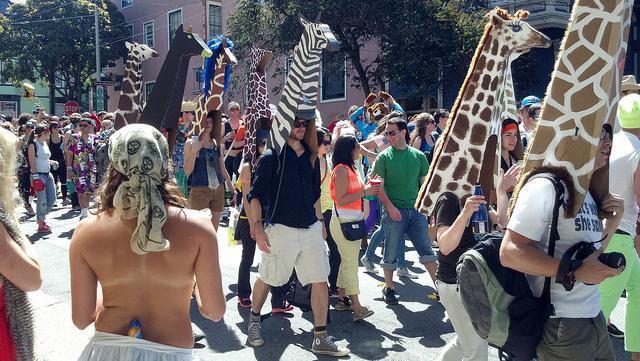How many giraffes can you see?
Give a very brief answer. 3. How many people are there?
Give a very brief answer. 9. How many of the bowls in the image contain mushrooms?
Give a very brief answer. 0. 